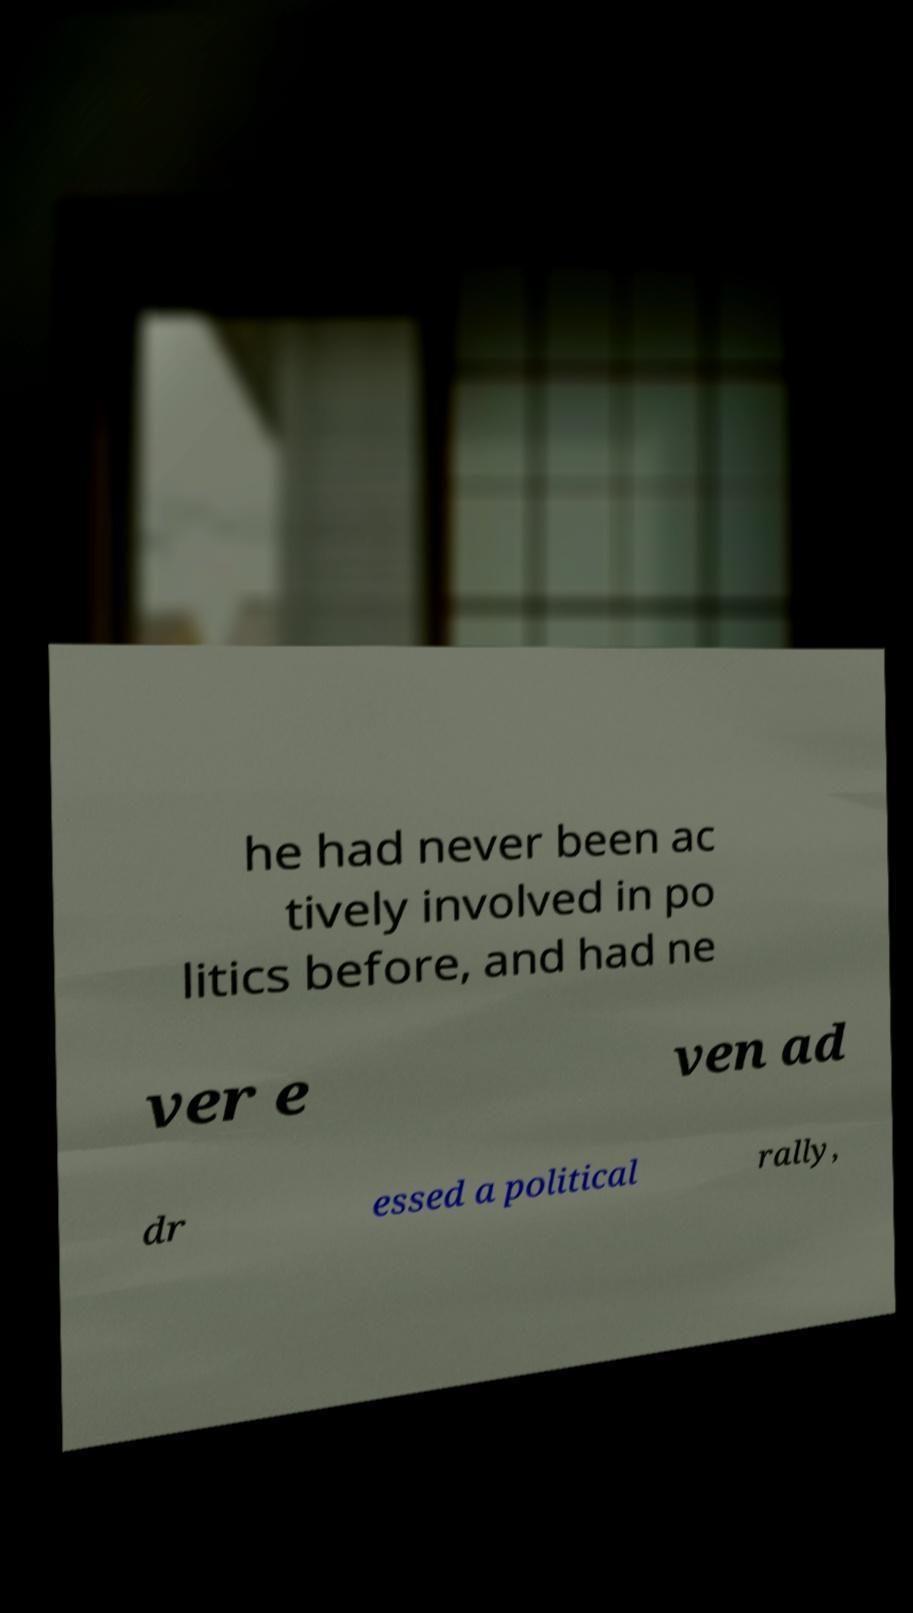What messages or text are displayed in this image? I need them in a readable, typed format. he had never been ac tively involved in po litics before, and had ne ver e ven ad dr essed a political rally, 